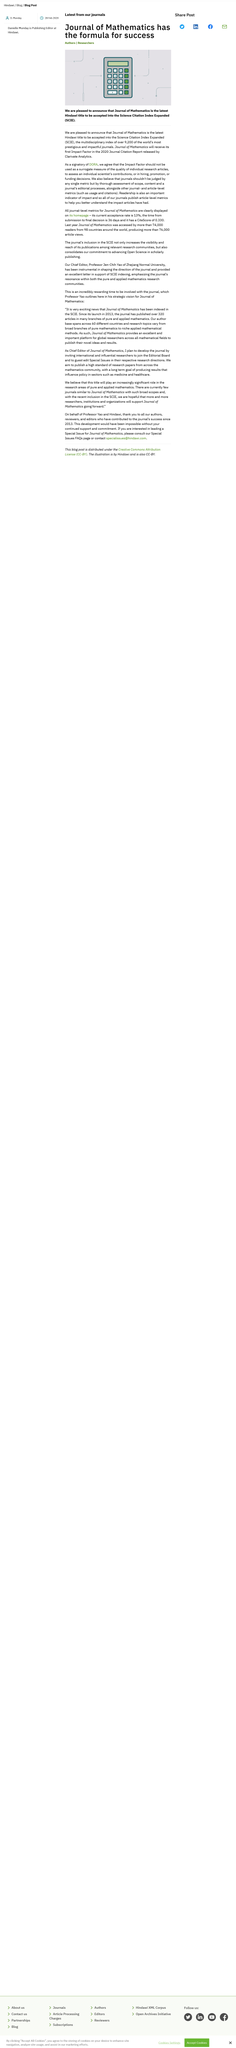Identify some key points in this picture. Last year, more than 74,000 readers accessed the journal of mathematics. Clarivate Analytics released the Journal of Mathematics. Science Citation Index Expanded (SCIE) is a database of academic journals in the fields of science, technology, and medicine, which is used to measure the citation impact of scientific research. 